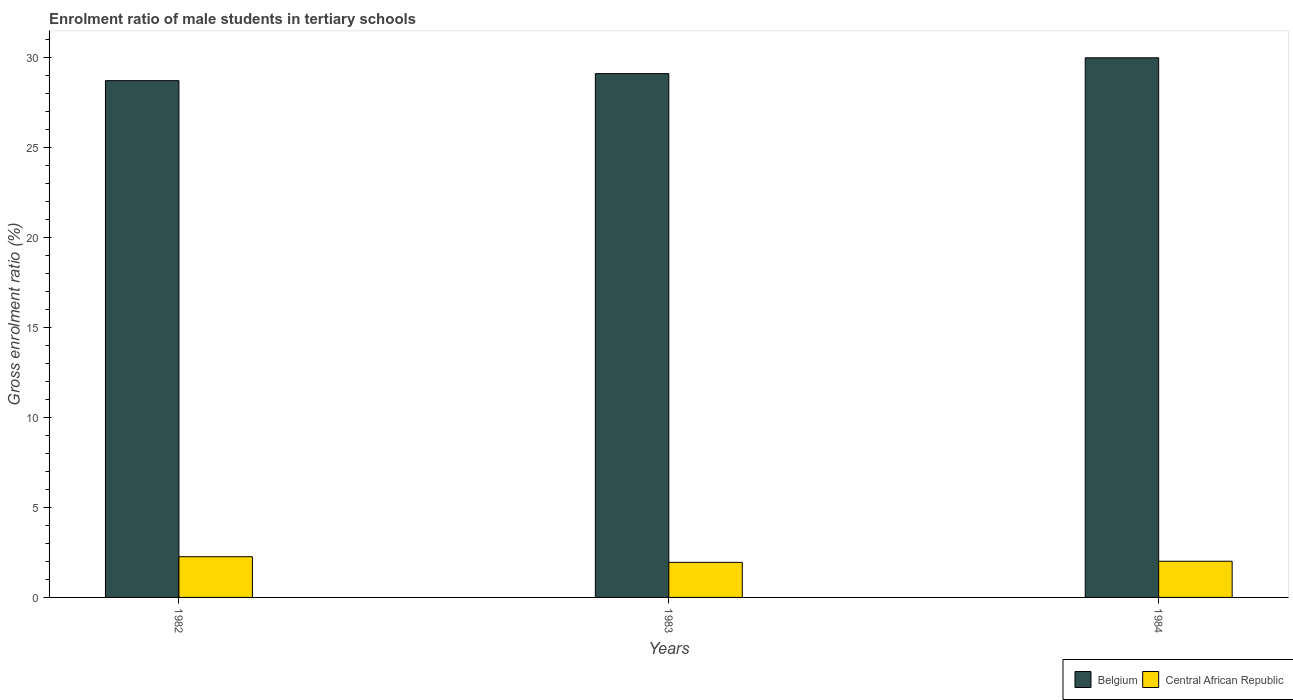Are the number of bars per tick equal to the number of legend labels?
Make the answer very short. Yes. Are the number of bars on each tick of the X-axis equal?
Make the answer very short. Yes. What is the label of the 2nd group of bars from the left?
Ensure brevity in your answer.  1983. What is the enrolment ratio of male students in tertiary schools in Belgium in 1984?
Ensure brevity in your answer.  30.01. Across all years, what is the maximum enrolment ratio of male students in tertiary schools in Belgium?
Your answer should be compact. 30.01. Across all years, what is the minimum enrolment ratio of male students in tertiary schools in Belgium?
Provide a short and direct response. 28.74. In which year was the enrolment ratio of male students in tertiary schools in Central African Republic minimum?
Provide a succinct answer. 1983. What is the total enrolment ratio of male students in tertiary schools in Central African Republic in the graph?
Make the answer very short. 6.23. What is the difference between the enrolment ratio of male students in tertiary schools in Belgium in 1982 and that in 1984?
Your answer should be compact. -1.27. What is the difference between the enrolment ratio of male students in tertiary schools in Central African Republic in 1982 and the enrolment ratio of male students in tertiary schools in Belgium in 1984?
Provide a short and direct response. -27.74. What is the average enrolment ratio of male students in tertiary schools in Belgium per year?
Your response must be concise. 29.29. In the year 1983, what is the difference between the enrolment ratio of male students in tertiary schools in Central African Republic and enrolment ratio of male students in tertiary schools in Belgium?
Your answer should be very brief. -27.18. What is the ratio of the enrolment ratio of male students in tertiary schools in Belgium in 1982 to that in 1984?
Your response must be concise. 0.96. What is the difference between the highest and the second highest enrolment ratio of male students in tertiary schools in Central African Republic?
Your response must be concise. 0.25. What is the difference between the highest and the lowest enrolment ratio of male students in tertiary schools in Belgium?
Offer a terse response. 1.27. What does the 2nd bar from the left in 1983 represents?
Ensure brevity in your answer.  Central African Republic. What does the 1st bar from the right in 1982 represents?
Provide a short and direct response. Central African Republic. How many bars are there?
Give a very brief answer. 6. What is the difference between two consecutive major ticks on the Y-axis?
Offer a terse response. 5. Are the values on the major ticks of Y-axis written in scientific E-notation?
Your response must be concise. No. Does the graph contain grids?
Offer a terse response. No. Where does the legend appear in the graph?
Provide a succinct answer. Bottom right. What is the title of the graph?
Offer a terse response. Enrolment ratio of male students in tertiary schools. Does "Iran" appear as one of the legend labels in the graph?
Keep it short and to the point. No. What is the label or title of the X-axis?
Give a very brief answer. Years. What is the Gross enrolment ratio (%) of Belgium in 1982?
Your answer should be very brief. 28.74. What is the Gross enrolment ratio (%) of Central African Republic in 1982?
Provide a succinct answer. 2.26. What is the Gross enrolment ratio (%) of Belgium in 1983?
Make the answer very short. 29.13. What is the Gross enrolment ratio (%) in Central African Republic in 1983?
Offer a terse response. 1.95. What is the Gross enrolment ratio (%) in Belgium in 1984?
Offer a very short reply. 30.01. What is the Gross enrolment ratio (%) in Central African Republic in 1984?
Offer a very short reply. 2.01. Across all years, what is the maximum Gross enrolment ratio (%) in Belgium?
Provide a short and direct response. 30.01. Across all years, what is the maximum Gross enrolment ratio (%) in Central African Republic?
Your answer should be compact. 2.26. Across all years, what is the minimum Gross enrolment ratio (%) in Belgium?
Offer a very short reply. 28.74. Across all years, what is the minimum Gross enrolment ratio (%) in Central African Republic?
Keep it short and to the point. 1.95. What is the total Gross enrolment ratio (%) of Belgium in the graph?
Ensure brevity in your answer.  87.87. What is the total Gross enrolment ratio (%) in Central African Republic in the graph?
Your answer should be compact. 6.23. What is the difference between the Gross enrolment ratio (%) in Belgium in 1982 and that in 1983?
Provide a short and direct response. -0.39. What is the difference between the Gross enrolment ratio (%) of Central African Republic in 1982 and that in 1983?
Keep it short and to the point. 0.31. What is the difference between the Gross enrolment ratio (%) of Belgium in 1982 and that in 1984?
Keep it short and to the point. -1.27. What is the difference between the Gross enrolment ratio (%) of Central African Republic in 1982 and that in 1984?
Provide a short and direct response. 0.25. What is the difference between the Gross enrolment ratio (%) of Belgium in 1983 and that in 1984?
Your answer should be compact. -0.88. What is the difference between the Gross enrolment ratio (%) in Central African Republic in 1983 and that in 1984?
Offer a very short reply. -0.06. What is the difference between the Gross enrolment ratio (%) in Belgium in 1982 and the Gross enrolment ratio (%) in Central African Republic in 1983?
Ensure brevity in your answer.  26.79. What is the difference between the Gross enrolment ratio (%) of Belgium in 1982 and the Gross enrolment ratio (%) of Central African Republic in 1984?
Your response must be concise. 26.72. What is the difference between the Gross enrolment ratio (%) in Belgium in 1983 and the Gross enrolment ratio (%) in Central African Republic in 1984?
Provide a succinct answer. 27.12. What is the average Gross enrolment ratio (%) in Belgium per year?
Your response must be concise. 29.29. What is the average Gross enrolment ratio (%) of Central African Republic per year?
Provide a short and direct response. 2.08. In the year 1982, what is the difference between the Gross enrolment ratio (%) of Belgium and Gross enrolment ratio (%) of Central African Republic?
Provide a succinct answer. 26.47. In the year 1983, what is the difference between the Gross enrolment ratio (%) in Belgium and Gross enrolment ratio (%) in Central African Republic?
Keep it short and to the point. 27.18. In the year 1984, what is the difference between the Gross enrolment ratio (%) in Belgium and Gross enrolment ratio (%) in Central African Republic?
Ensure brevity in your answer.  27.99. What is the ratio of the Gross enrolment ratio (%) of Belgium in 1982 to that in 1983?
Your response must be concise. 0.99. What is the ratio of the Gross enrolment ratio (%) of Central African Republic in 1982 to that in 1983?
Your answer should be very brief. 1.16. What is the ratio of the Gross enrolment ratio (%) of Belgium in 1982 to that in 1984?
Make the answer very short. 0.96. What is the ratio of the Gross enrolment ratio (%) in Central African Republic in 1982 to that in 1984?
Your answer should be compact. 1.13. What is the ratio of the Gross enrolment ratio (%) of Belgium in 1983 to that in 1984?
Keep it short and to the point. 0.97. What is the ratio of the Gross enrolment ratio (%) in Central African Republic in 1983 to that in 1984?
Give a very brief answer. 0.97. What is the difference between the highest and the second highest Gross enrolment ratio (%) of Belgium?
Offer a terse response. 0.88. What is the difference between the highest and the second highest Gross enrolment ratio (%) in Central African Republic?
Provide a succinct answer. 0.25. What is the difference between the highest and the lowest Gross enrolment ratio (%) of Belgium?
Make the answer very short. 1.27. What is the difference between the highest and the lowest Gross enrolment ratio (%) of Central African Republic?
Your answer should be very brief. 0.31. 